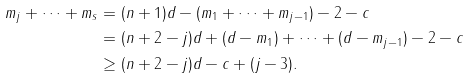<formula> <loc_0><loc_0><loc_500><loc_500>m _ { j } + \dots + m _ { s } & = ( n + 1 ) d - ( m _ { 1 } + \dots + m _ { j - 1 } ) - 2 - c \\ & = ( n + 2 - j ) d + ( d - m _ { 1 } ) + \dots + ( d - m _ { j - 1 } ) - 2 - c \\ & \geq ( n + 2 - j ) d - c + ( j - 3 ) .</formula> 